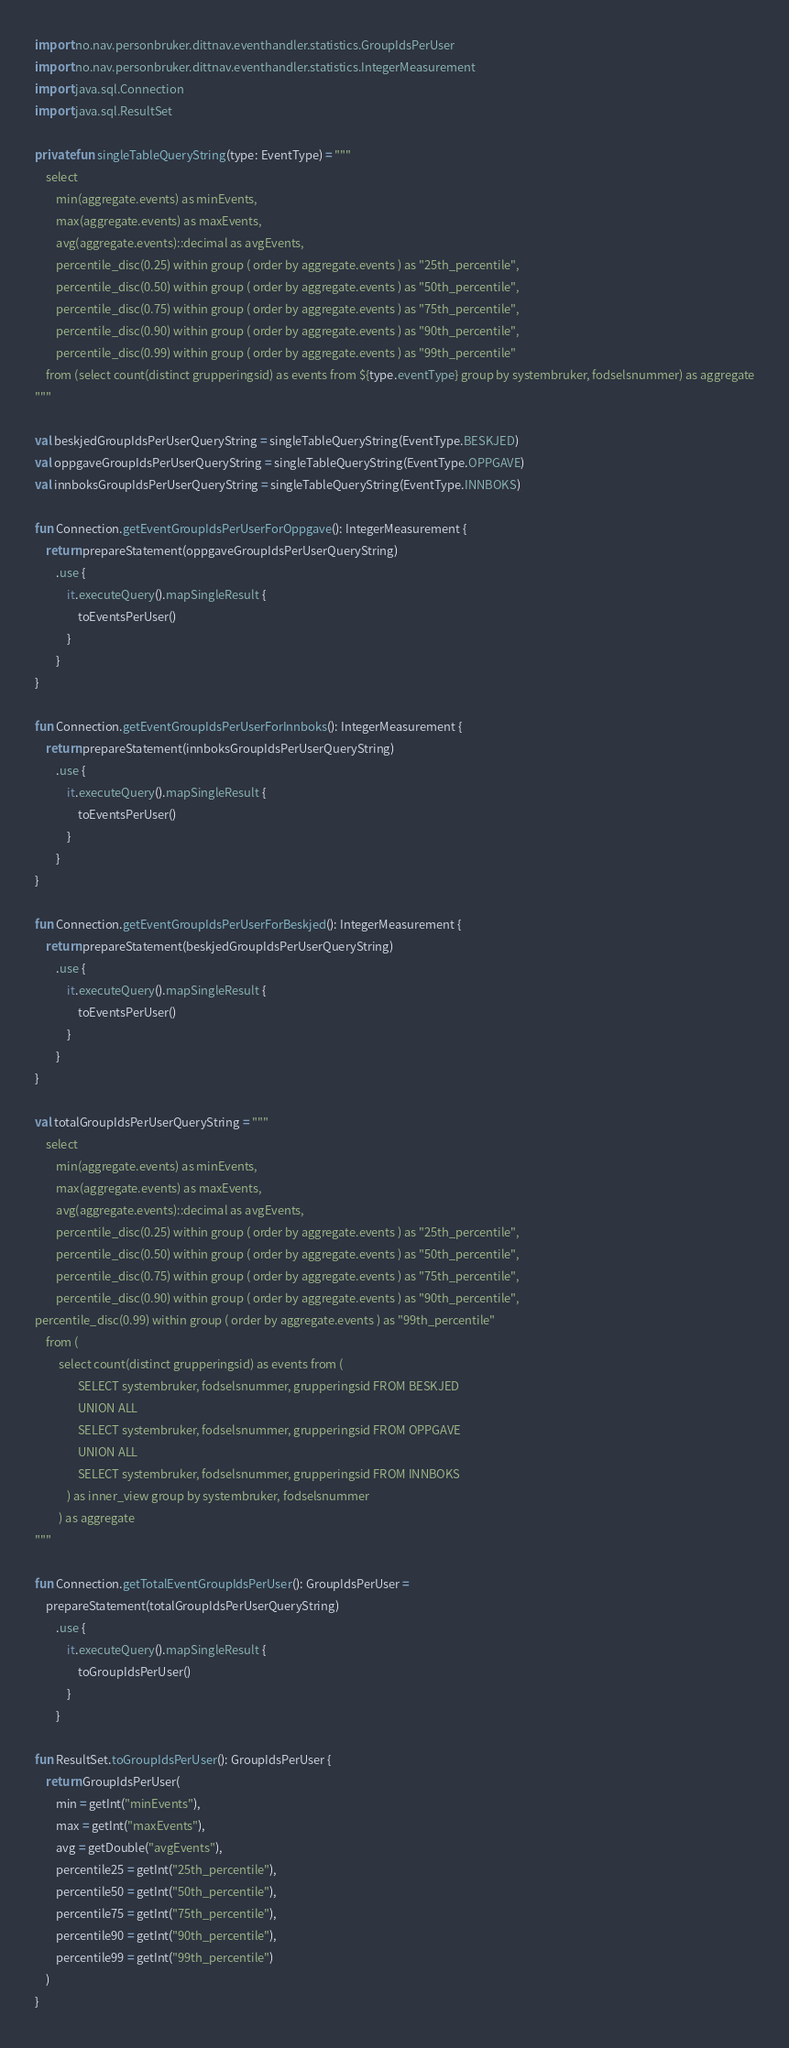<code> <loc_0><loc_0><loc_500><loc_500><_Kotlin_>import no.nav.personbruker.dittnav.eventhandler.statistics.GroupIdsPerUser
import no.nav.personbruker.dittnav.eventhandler.statistics.IntegerMeasurement
import java.sql.Connection
import java.sql.ResultSet

private fun singleTableQueryString(type: EventType) = """
    select
        min(aggregate.events) as minEvents,
        max(aggregate.events) as maxEvents,
        avg(aggregate.events)::decimal as avgEvents,
        percentile_disc(0.25) within group ( order by aggregate.events ) as "25th_percentile",
        percentile_disc(0.50) within group ( order by aggregate.events ) as "50th_percentile",
        percentile_disc(0.75) within group ( order by aggregate.events ) as "75th_percentile",
        percentile_disc(0.90) within group ( order by aggregate.events ) as "90th_percentile",
        percentile_disc(0.99) within group ( order by aggregate.events ) as "99th_percentile"
    from (select count(distinct grupperingsid) as events from ${type.eventType} group by systembruker, fodselsnummer) as aggregate
"""

val beskjedGroupIdsPerUserQueryString = singleTableQueryString(EventType.BESKJED)
val oppgaveGroupIdsPerUserQueryString = singleTableQueryString(EventType.OPPGAVE)
val innboksGroupIdsPerUserQueryString = singleTableQueryString(EventType.INNBOKS)

fun Connection.getEventGroupIdsPerUserForOppgave(): IntegerMeasurement {
    return prepareStatement(oppgaveGroupIdsPerUserQueryString)
        .use {
            it.executeQuery().mapSingleResult {
                toEventsPerUser()
            }
        }
}

fun Connection.getEventGroupIdsPerUserForInnboks(): IntegerMeasurement {
    return prepareStatement(innboksGroupIdsPerUserQueryString)
        .use {
            it.executeQuery().mapSingleResult {
                toEventsPerUser()
            }
        }
}

fun Connection.getEventGroupIdsPerUserForBeskjed(): IntegerMeasurement {
    return prepareStatement(beskjedGroupIdsPerUserQueryString)
        .use {
            it.executeQuery().mapSingleResult {
                toEventsPerUser()
            }
        }
}

val totalGroupIdsPerUserQueryString = """
    select
        min(aggregate.events) as minEvents,
        max(aggregate.events) as maxEvents,
        avg(aggregate.events)::decimal as avgEvents,
        percentile_disc(0.25) within group ( order by aggregate.events ) as "25th_percentile",
        percentile_disc(0.50) within group ( order by aggregate.events ) as "50th_percentile",
        percentile_disc(0.75) within group ( order by aggregate.events ) as "75th_percentile",
        percentile_disc(0.90) within group ( order by aggregate.events ) as "90th_percentile",
percentile_disc(0.99) within group ( order by aggregate.events ) as "99th_percentile"
    from (
         select count(distinct grupperingsid) as events from (
                SELECT systembruker, fodselsnummer, grupperingsid FROM BESKJED
                UNION ALL
                SELECT systembruker, fodselsnummer, grupperingsid FROM OPPGAVE
                UNION ALL
                SELECT systembruker, fodselsnummer, grupperingsid FROM INNBOKS
            ) as inner_view group by systembruker, fodselsnummer
         ) as aggregate
"""

fun Connection.getTotalEventGroupIdsPerUser(): GroupIdsPerUser =
    prepareStatement(totalGroupIdsPerUserQueryString)
        .use {
            it.executeQuery().mapSingleResult {
                toGroupIdsPerUser()
            }
        }

fun ResultSet.toGroupIdsPerUser(): GroupIdsPerUser {
    return GroupIdsPerUser(
        min = getInt("minEvents"),
        max = getInt("maxEvents"),
        avg = getDouble("avgEvents"),
        percentile25 = getInt("25th_percentile"),
        percentile50 = getInt("50th_percentile"),
        percentile75 = getInt("75th_percentile"),
        percentile90 = getInt("90th_percentile"),
        percentile99 = getInt("99th_percentile")
    )
}
</code> 